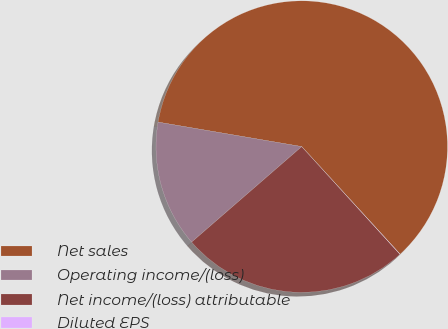Convert chart to OTSL. <chart><loc_0><loc_0><loc_500><loc_500><pie_chart><fcel>Net sales<fcel>Operating income/(loss)<fcel>Net income/(loss) attributable<fcel>Diluted EPS<nl><fcel>60.53%<fcel>14.06%<fcel>25.4%<fcel>0.02%<nl></chart> 